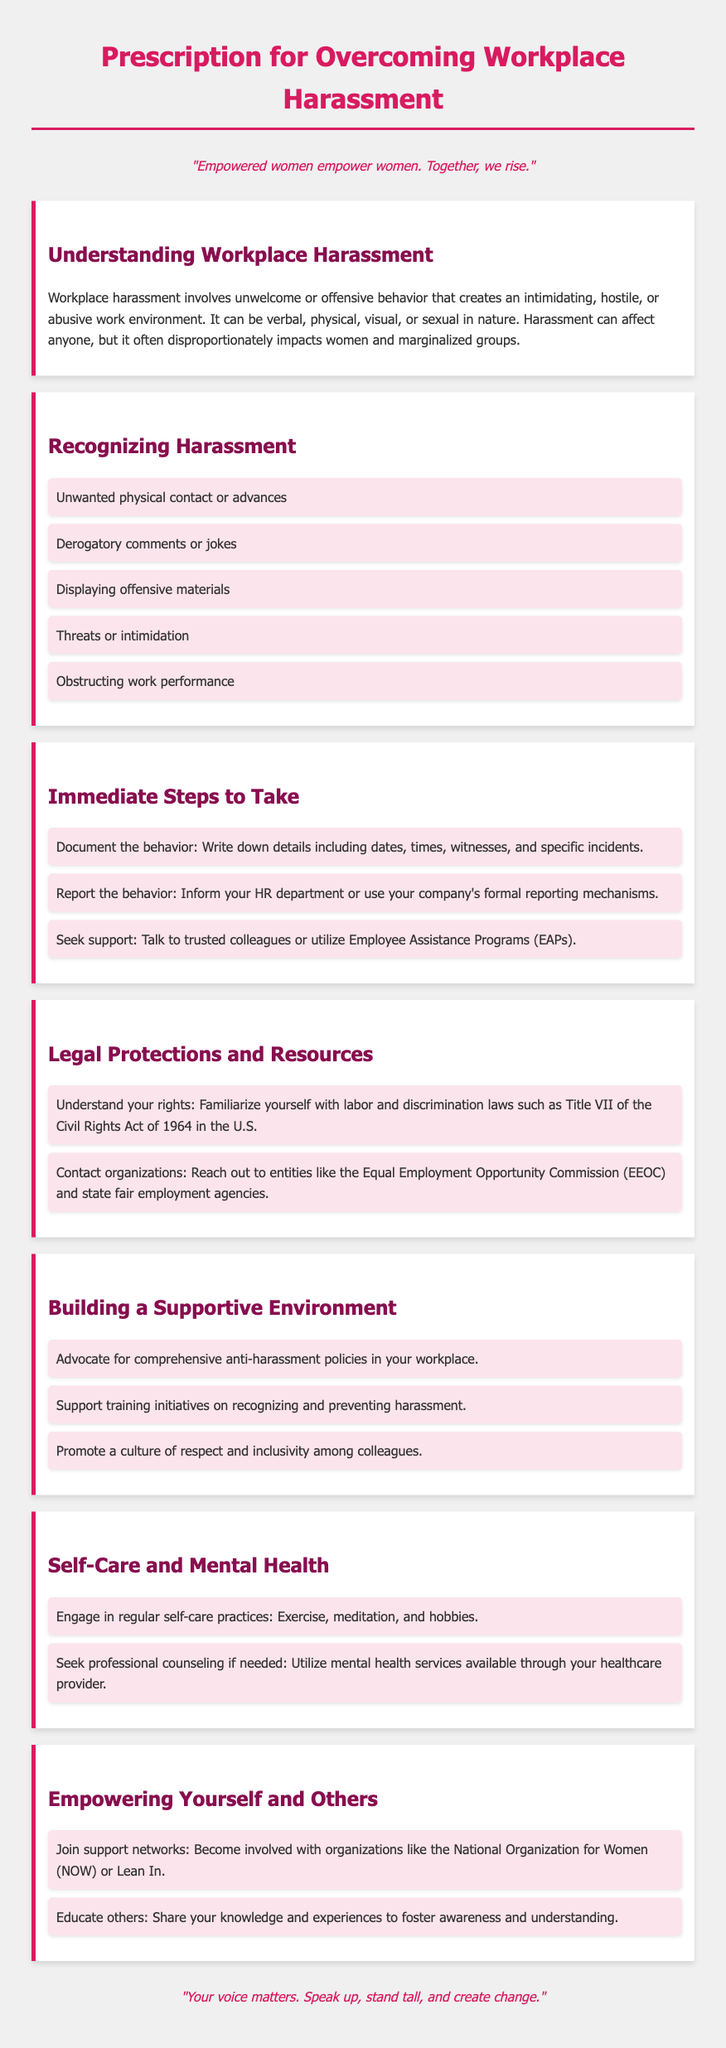What is the title of the document? The title is found at the top of the document in a larger font and is clearly stated.
Answer: Prescription for Overcoming Workplace Harassment What are the immediate steps to take? Immediate steps are listed under a specific heading, detailing what actions to take in response to harassment.
Answer: Document the behavior, Report the behavior, Seek support Which act is mentioned as a legal protection? The document mentions specific legislation related to workplace harassment, highlighting its importance.
Answer: Title VII of the Civil Rights Act of 1964 How many strategies are suggested in the "Building a Supportive Environment" section? The number of strategies can be counted from the bullet points listed in that section.
Answer: Three What is one way to engage in self-care? Self-care practices are suggested in a specific section, and examples are provided.
Answer: Exercise Who might you contact for legal assistance? The document suggests reaching out to organizations for guidance on legal matters.
Answer: Equal Employment Opportunity Commission (EEOC) What quote is mentioned about empowerment? A significant quote about empowerment is included in the document, emphasizing its message.
Answer: "Empowered women empower women. Together, we rise." What should you do if you need professional counseling? This aspect is discussed under a section dedicated to mental health, specifying the action to take.
Answer: Utilize mental health services available through your healthcare provider 